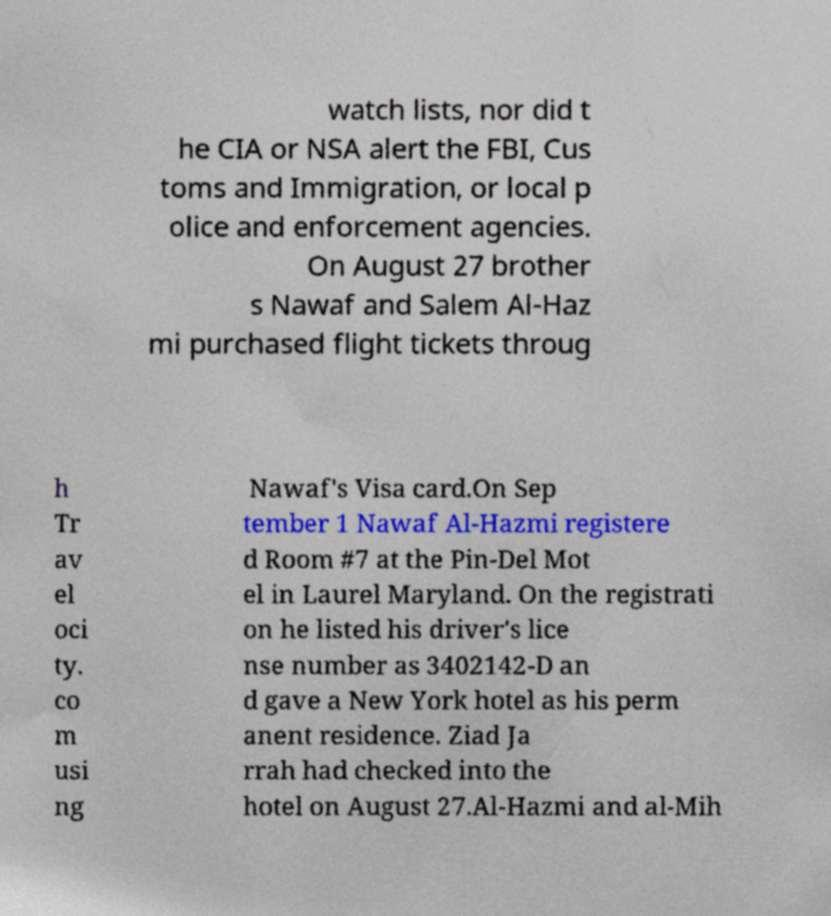There's text embedded in this image that I need extracted. Can you transcribe it verbatim? watch lists, nor did t he CIA or NSA alert the FBI, Cus toms and Immigration, or local p olice and enforcement agencies. On August 27 brother s Nawaf and Salem Al-Haz mi purchased flight tickets throug h Tr av el oci ty. co m usi ng Nawaf's Visa card.On Sep tember 1 Nawaf Al-Hazmi registere d Room #7 at the Pin-Del Mot el in Laurel Maryland. On the registrati on he listed his driver's lice nse number as 3402142-D an d gave a New York hotel as his perm anent residence. Ziad Ja rrah had checked into the hotel on August 27.Al-Hazmi and al-Mih 